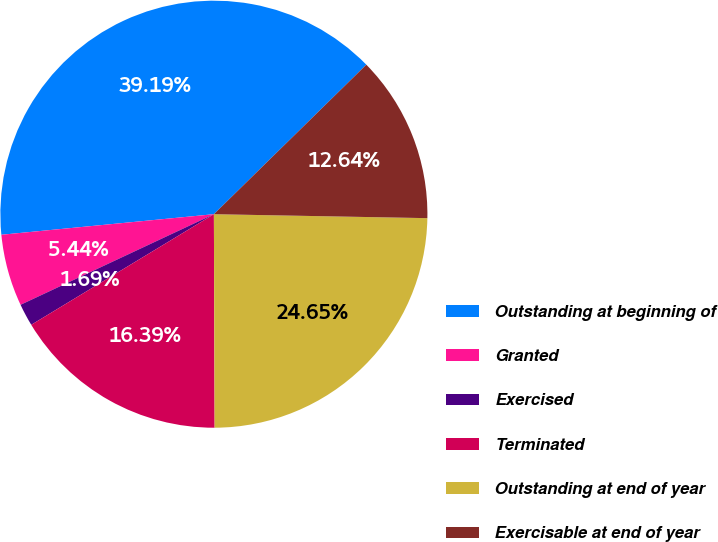<chart> <loc_0><loc_0><loc_500><loc_500><pie_chart><fcel>Outstanding at beginning of<fcel>Granted<fcel>Exercised<fcel>Terminated<fcel>Outstanding at end of year<fcel>Exercisable at end of year<nl><fcel>39.19%<fcel>5.44%<fcel>1.69%<fcel>16.39%<fcel>24.65%<fcel>12.64%<nl></chart> 